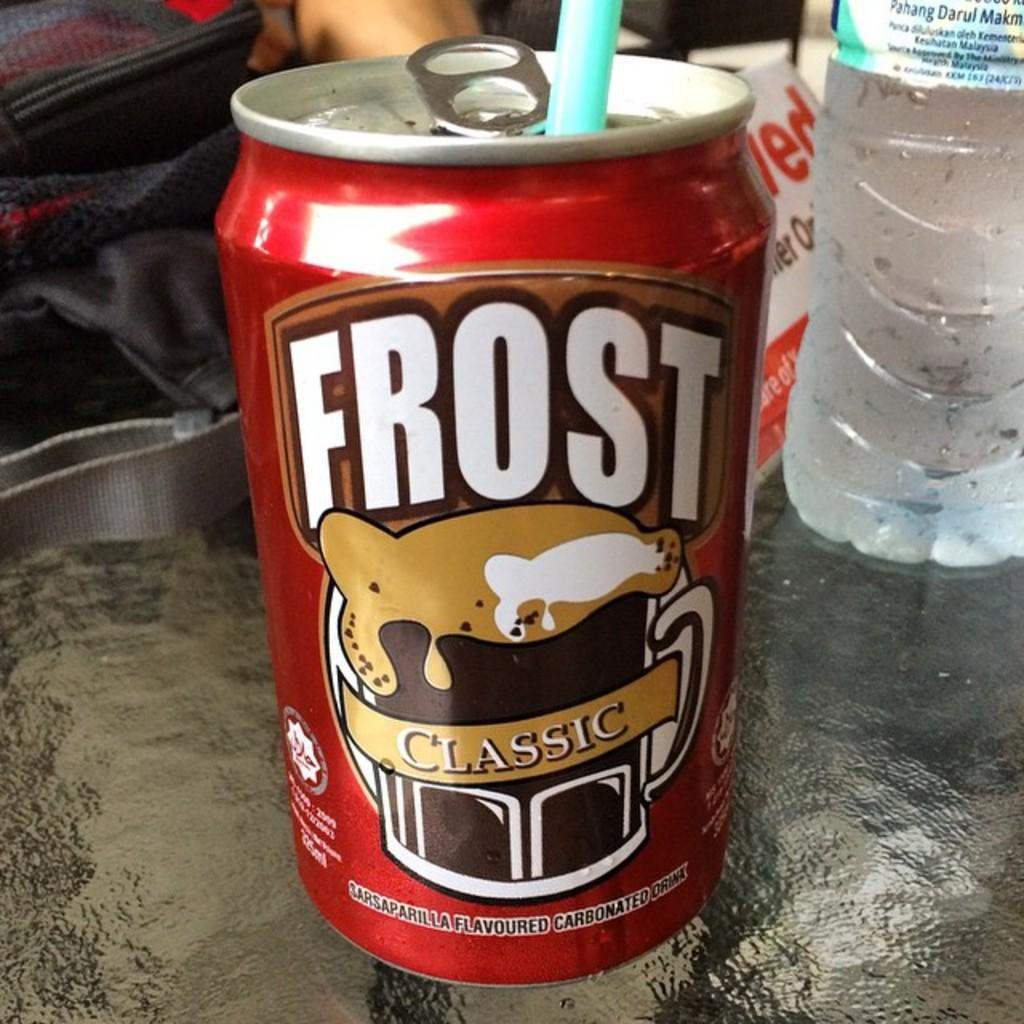<image>
Render a clear and concise summary of the photo. a close up of a Frost root beer Classic can with a straw 